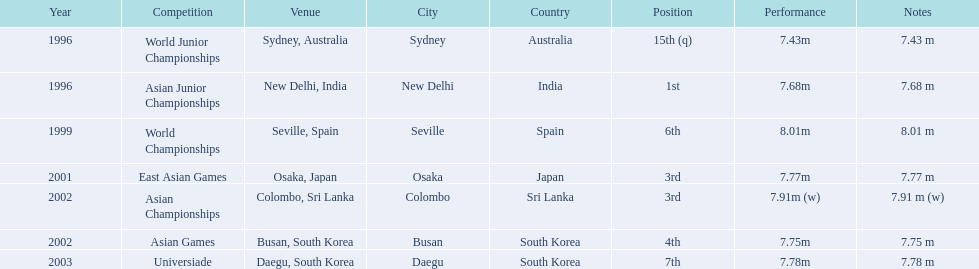What was the venue when he placed first? New Delhi, India. 